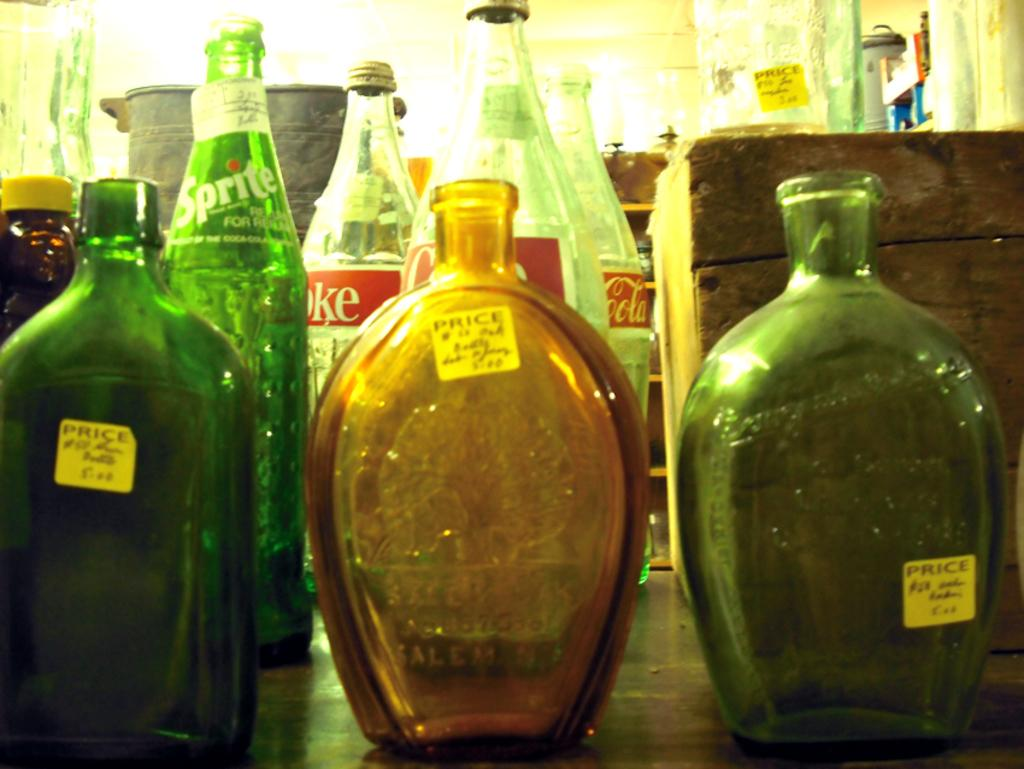<image>
Offer a succinct explanation of the picture presented. some bottles that have the word price on them 